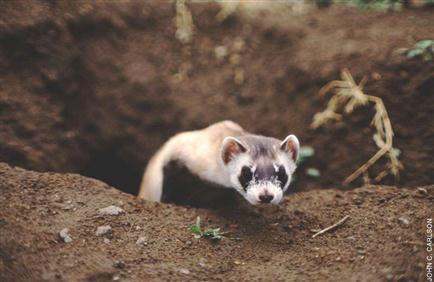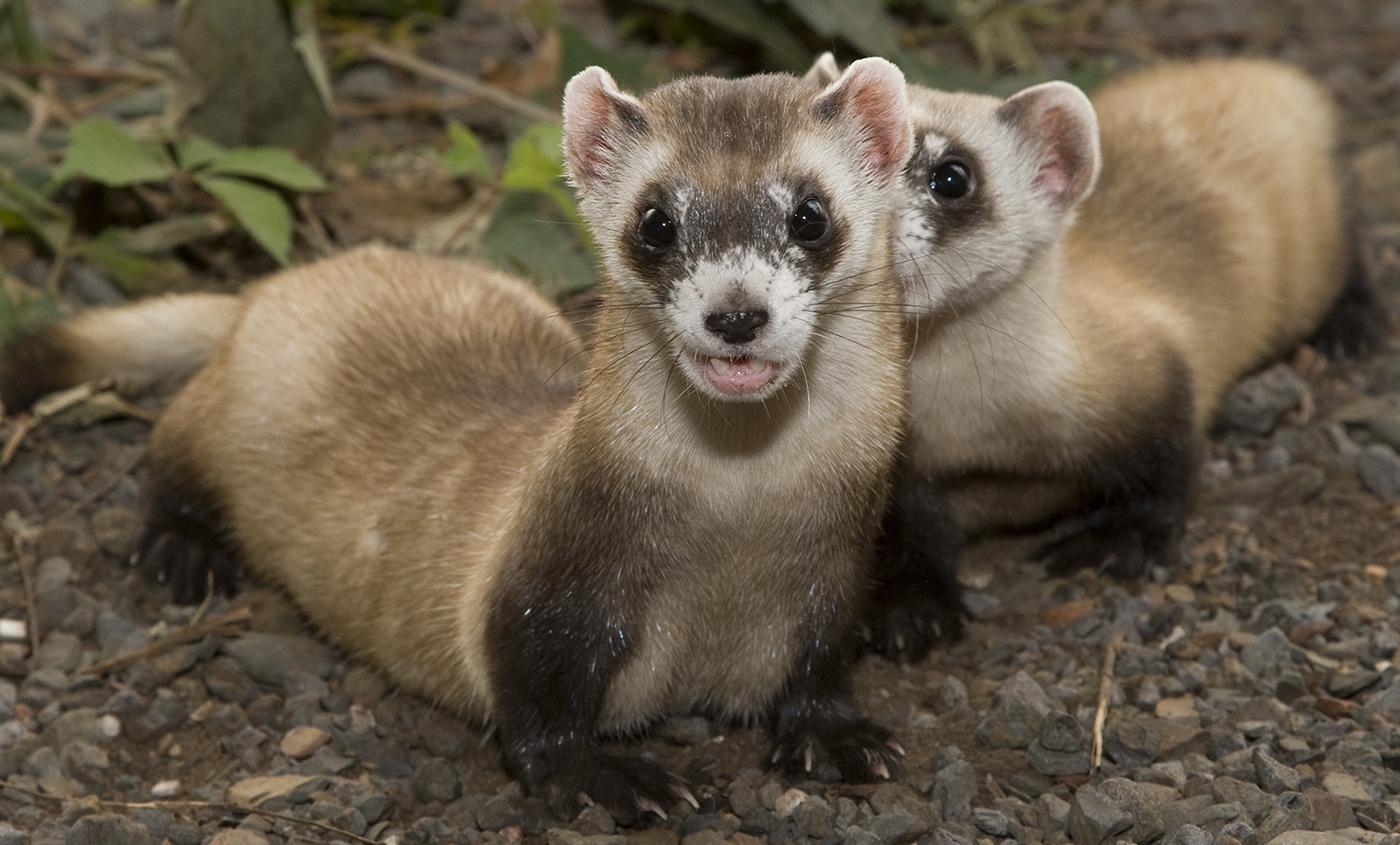The first image is the image on the left, the second image is the image on the right. Examine the images to the left and right. Is the description "The left image shows one ferret emerging from a hole in the ground, and the right image contains multiple ferrets." accurate? Answer yes or no. Yes. 